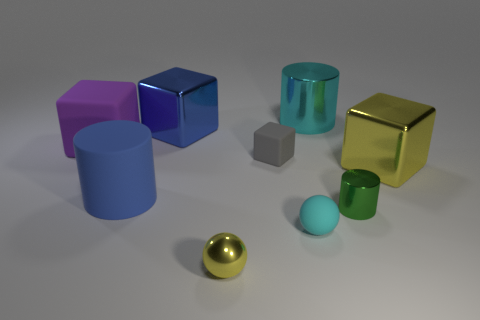Subtract all large rubber blocks. How many blocks are left? 3 Subtract all yellow spheres. How many spheres are left? 1 Add 1 big blocks. How many objects exist? 10 Subtract 2 cubes. How many cubes are left? 2 Subtract all purple balls. Subtract all gray cylinders. How many balls are left? 2 Subtract all blue spheres. How many blue cylinders are left? 1 Subtract all brown matte balls. Subtract all blue metallic things. How many objects are left? 8 Add 8 small rubber spheres. How many small rubber spheres are left? 9 Add 6 big blue rubber cubes. How many big blue rubber cubes exist? 6 Subtract 0 gray spheres. How many objects are left? 9 